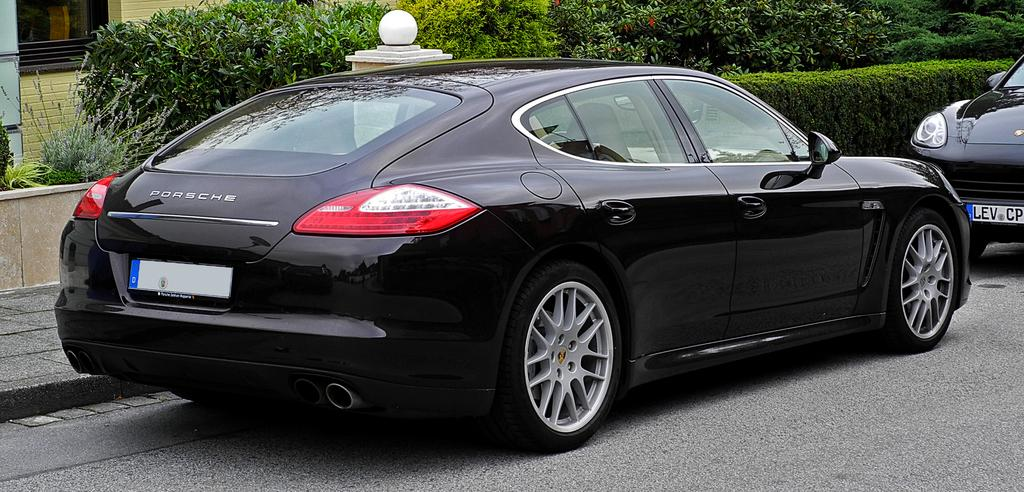What can be seen on the road in the image? There are cars parked on the road in the image. What is the purpose of the footpath visible in the image? The footpath is for pedestrians to walk on. What is the function of the street lamp in the image? The street lamp provides light at night. What type of vegetation is present in the image? There is a group of plants in the image. What structure is visible in the image? There is a wall visible in the image. What type of shock can be seen in the image? There is no shock present in the image. What shape is the power source in the image? There is no power source mentioned in the image, so it cannot be determined what shape it might be. 